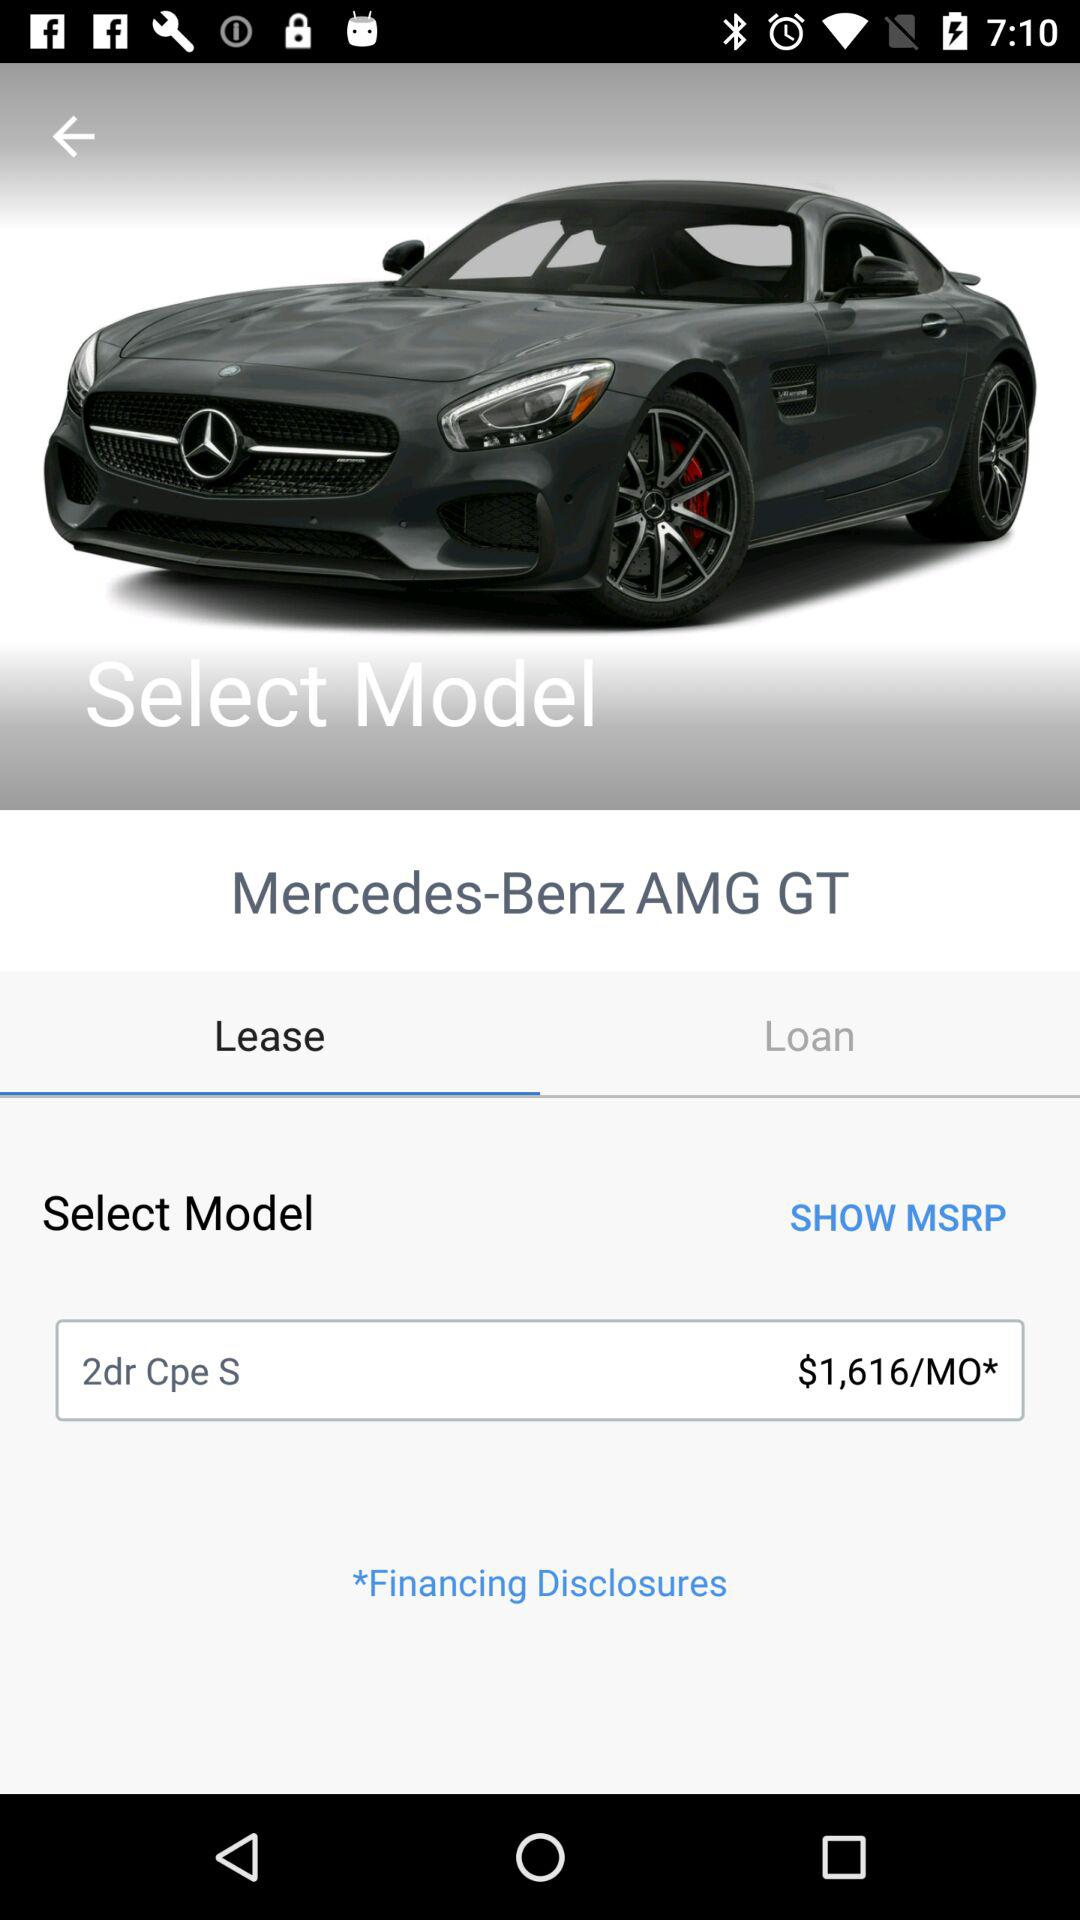What's the selected tab? The selected tab is "Lease". 